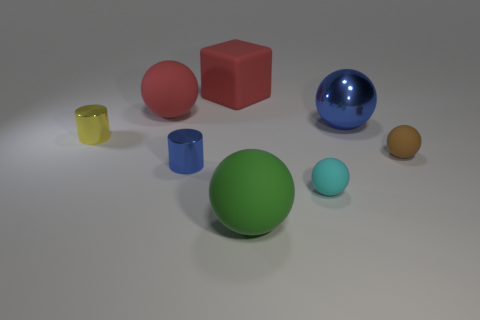What number of things are tiny shiny cylinders or blue objects that are right of the tiny blue metallic cylinder?
Ensure brevity in your answer.  3. Are there fewer yellow metallic cylinders than tiny green metallic balls?
Your response must be concise. No. What is the color of the large rubber ball on the left side of the big object in front of the brown sphere?
Provide a short and direct response. Red. What is the material of the brown object that is the same shape as the big green rubber thing?
Provide a succinct answer. Rubber. What number of rubber things are either big blue objects or small purple cubes?
Offer a very short reply. 0. Does the sphere that is right of the large blue metal ball have the same material as the large thing that is in front of the tiny yellow cylinder?
Ensure brevity in your answer.  Yes. Are there any tiny cyan rubber cubes?
Offer a terse response. No. There is a blue thing that is on the right side of the green matte sphere; is its shape the same as the big red matte object in front of the large rubber block?
Provide a succinct answer. Yes. Is there a big block that has the same material as the red ball?
Your response must be concise. Yes. Does the yellow thing in front of the big matte cube have the same material as the big green object?
Offer a terse response. No. 